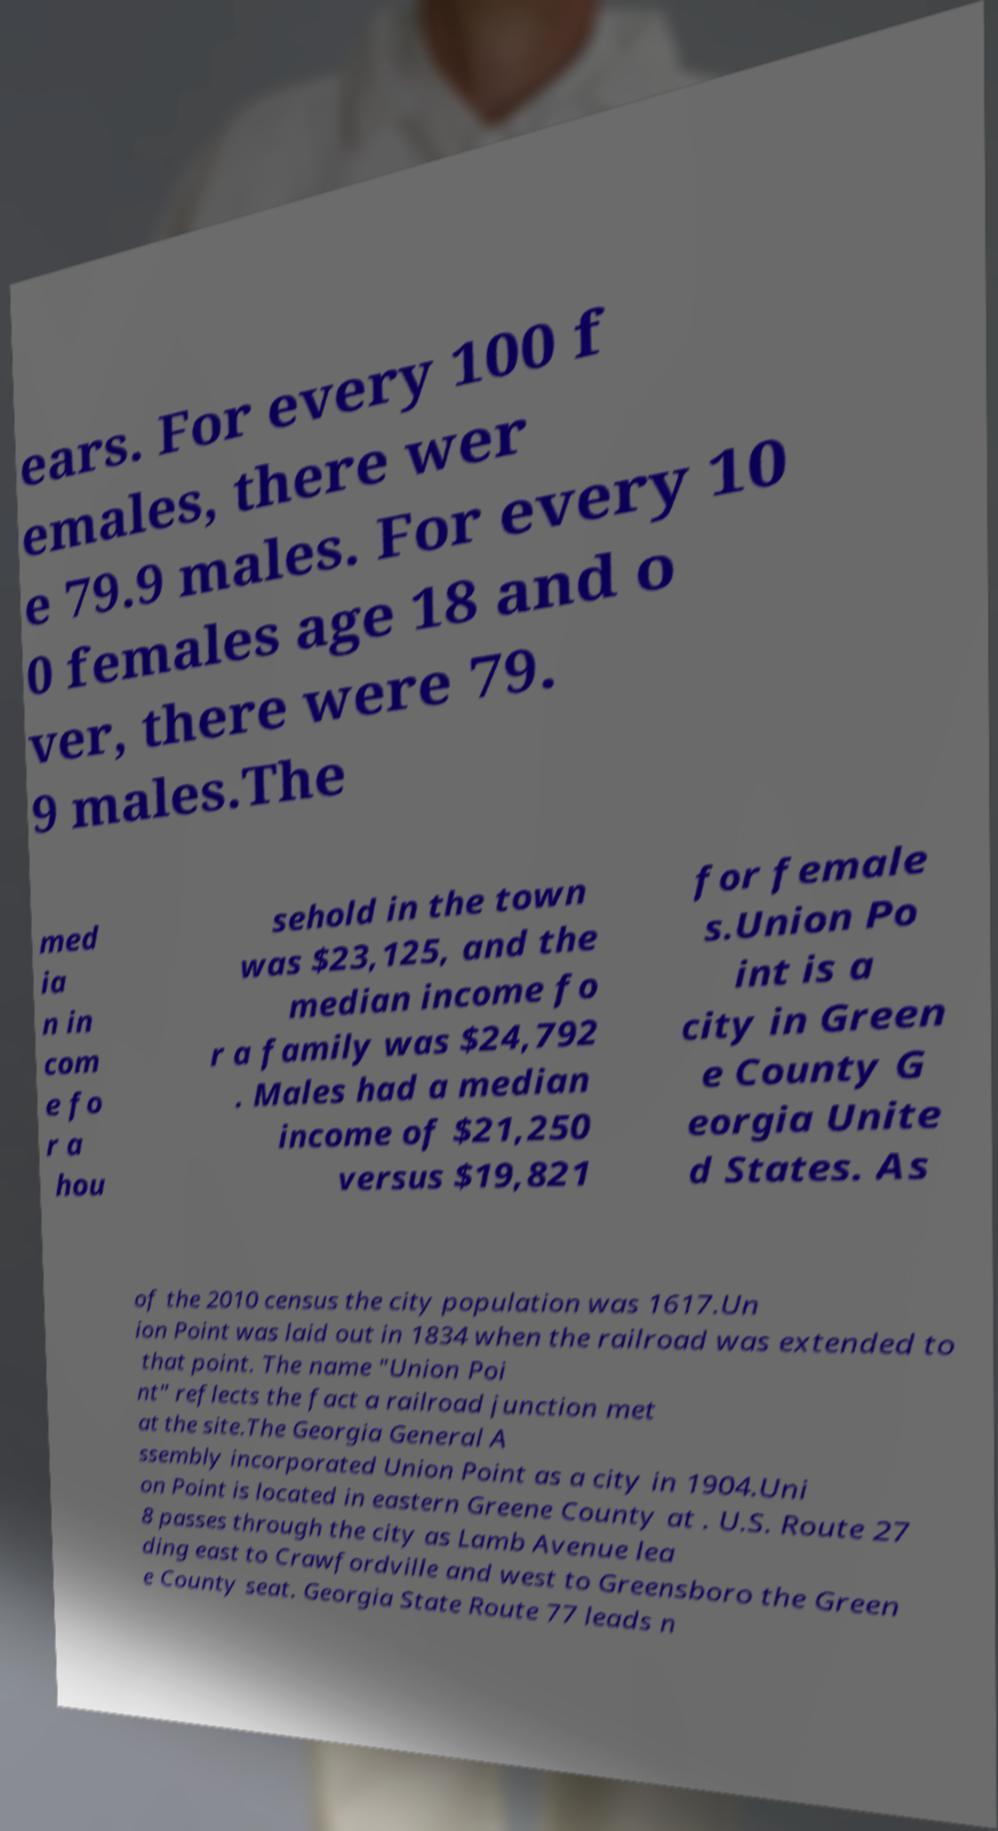Please identify and transcribe the text found in this image. ears. For every 100 f emales, there wer e 79.9 males. For every 10 0 females age 18 and o ver, there were 79. 9 males.The med ia n in com e fo r a hou sehold in the town was $23,125, and the median income fo r a family was $24,792 . Males had a median income of $21,250 versus $19,821 for female s.Union Po int is a city in Green e County G eorgia Unite d States. As of the 2010 census the city population was 1617.Un ion Point was laid out in 1834 when the railroad was extended to that point. The name "Union Poi nt" reflects the fact a railroad junction met at the site.The Georgia General A ssembly incorporated Union Point as a city in 1904.Uni on Point is located in eastern Greene County at . U.S. Route 27 8 passes through the city as Lamb Avenue lea ding east to Crawfordville and west to Greensboro the Green e County seat. Georgia State Route 77 leads n 